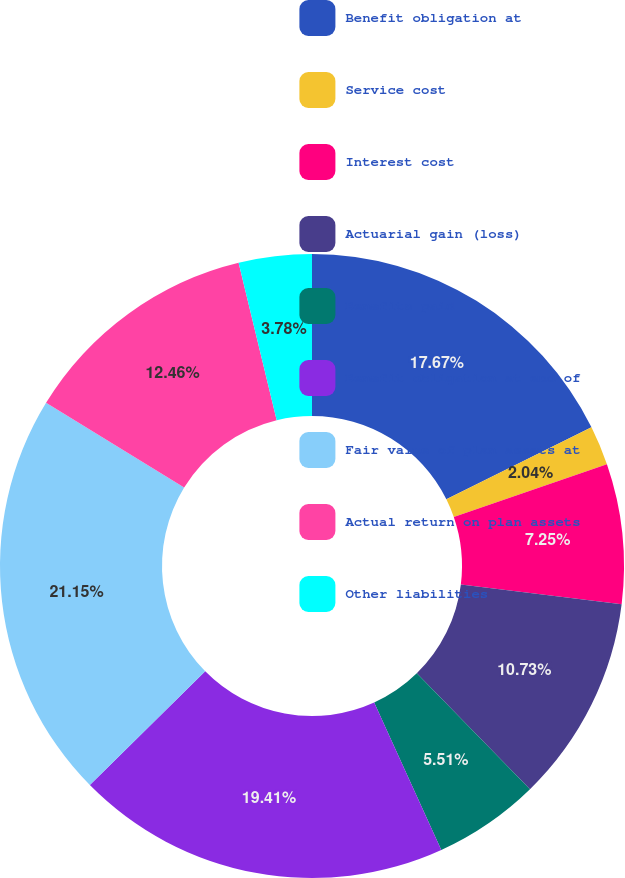<chart> <loc_0><loc_0><loc_500><loc_500><pie_chart><fcel>Benefit obligation at<fcel>Service cost<fcel>Interest cost<fcel>Actuarial gain (loss)<fcel>Benefits paid<fcel>Benefit obligation at end of<fcel>Fair value of plan assets at<fcel>Actual return on plan assets<fcel>Other liabilities<nl><fcel>17.67%<fcel>2.04%<fcel>7.25%<fcel>10.73%<fcel>5.51%<fcel>19.41%<fcel>21.15%<fcel>12.46%<fcel>3.78%<nl></chart> 